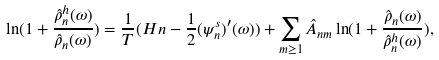Convert formula to latex. <formula><loc_0><loc_0><loc_500><loc_500>\ln ( 1 + \frac { \hat { \rho } _ { n } ^ { h } ( \omega ) } { \hat { \rho } _ { n } ( \omega ) } ) = \frac { 1 } { T } ( H n - \frac { 1 } { 2 } ( \psi ^ { s } _ { n } ) ^ { \prime } ( \omega ) ) + \sum _ { m \geq 1 } \hat { A } _ { n m } \ln ( 1 + \frac { \hat { \rho } _ { n } ( \omega ) } { \hat { \rho } _ { n } ^ { h } ( \omega ) } ) ,</formula> 